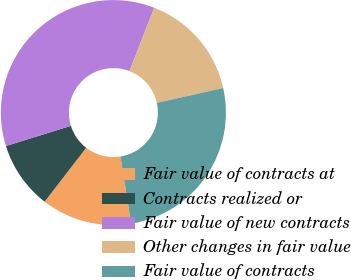Convert chart. <chart><loc_0><loc_0><loc_500><loc_500><pie_chart><fcel>Fair value of contracts at<fcel>Contracts realized or<fcel>Fair value of new contracts<fcel>Other changes in fair value<fcel>Fair value of contracts<nl><fcel>12.99%<fcel>9.74%<fcel>35.71%<fcel>15.58%<fcel>25.97%<nl></chart> 